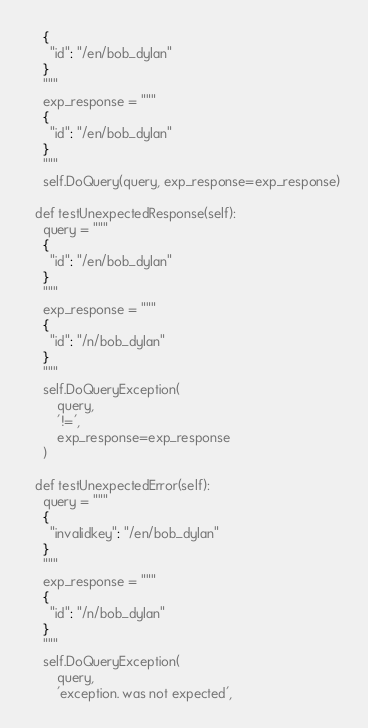Convert code to text. <code><loc_0><loc_0><loc_500><loc_500><_Python_>    {
      "id": "/en/bob_dylan"
    }
    """
    exp_response = """
    {
      "id": "/en/bob_dylan"
    }
    """
    self.DoQuery(query, exp_response=exp_response)

  def testUnexpectedResponse(self):
    query = """
    {
      "id": "/en/bob_dylan"
    }
    """
    exp_response = """
    {
      "id": "/n/bob_dylan"
    }
    """
    self.DoQueryException(
        query,
        '!=',
        exp_response=exp_response
    )

  def testUnexpectedError(self):
    query = """
    {
      "invalidkey": "/en/bob_dylan"
    }
    """
    exp_response = """
    {
      "id": "/n/bob_dylan"
    }
    """
    self.DoQueryException(
        query,
        'exception. was not expected',</code> 